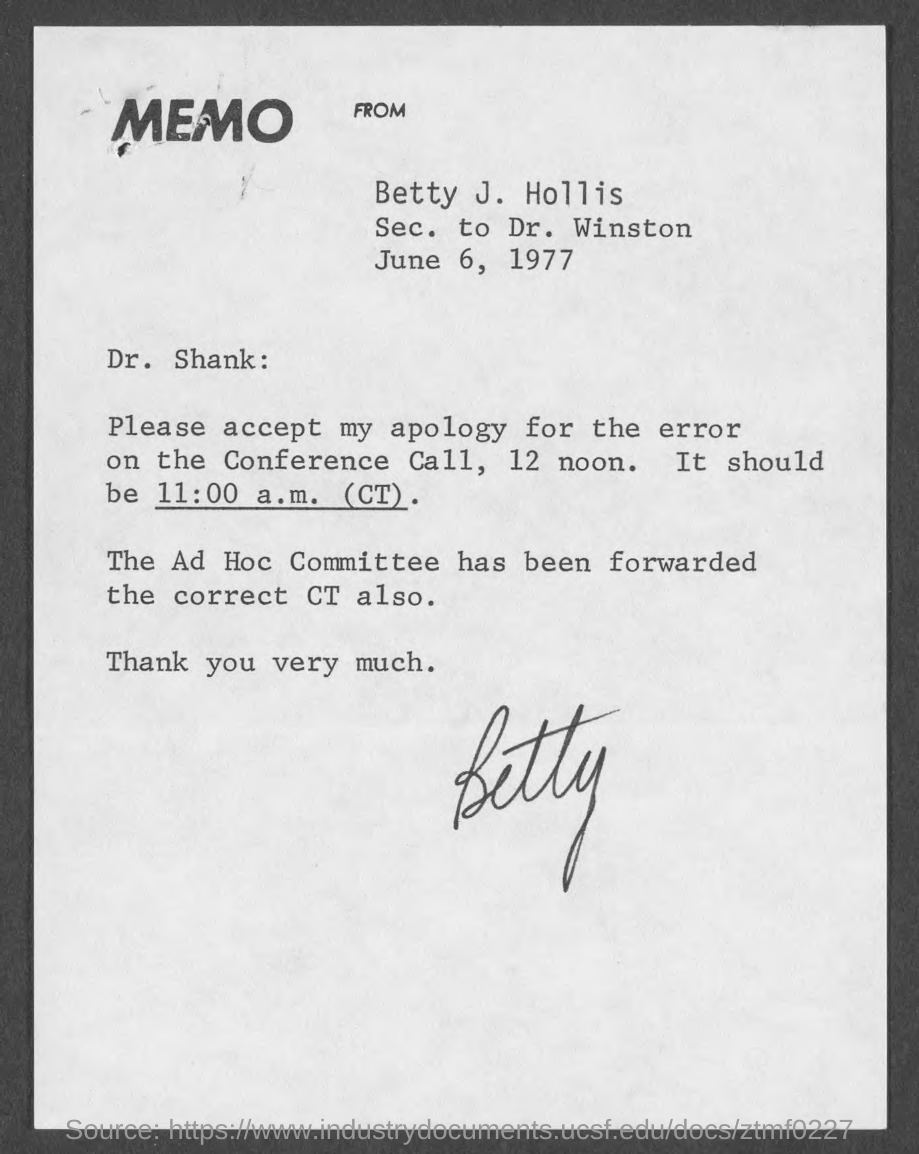Give some essential details in this illustration. The memo is dated June 6, 1977. The secretary is Betty J. Hollis to Dr. Winston. 